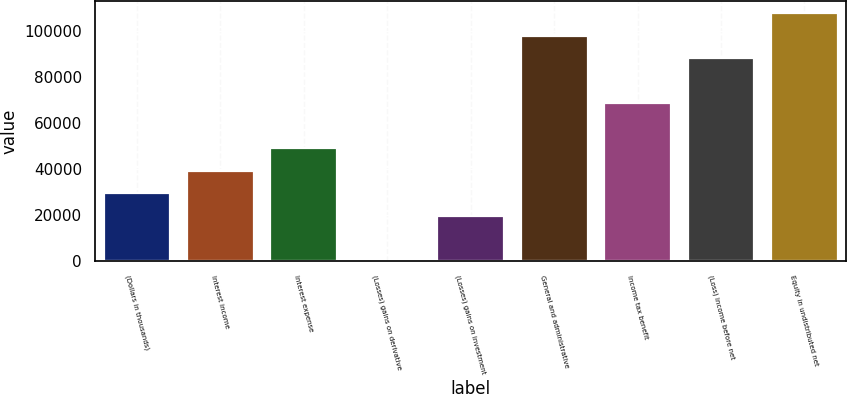Convert chart to OTSL. <chart><loc_0><loc_0><loc_500><loc_500><bar_chart><fcel>(Dollars in thousands)<fcel>Interest income<fcel>Interest expense<fcel>(Losses) gains on derivative<fcel>(Losses) gains on investment<fcel>General and administrative<fcel>Income tax benefit<fcel>(Loss) income before net<fcel>Equity in undistributed net<nl><fcel>29471<fcel>39228<fcel>48985<fcel>200<fcel>19714<fcel>97770<fcel>68499<fcel>88013<fcel>107527<nl></chart> 